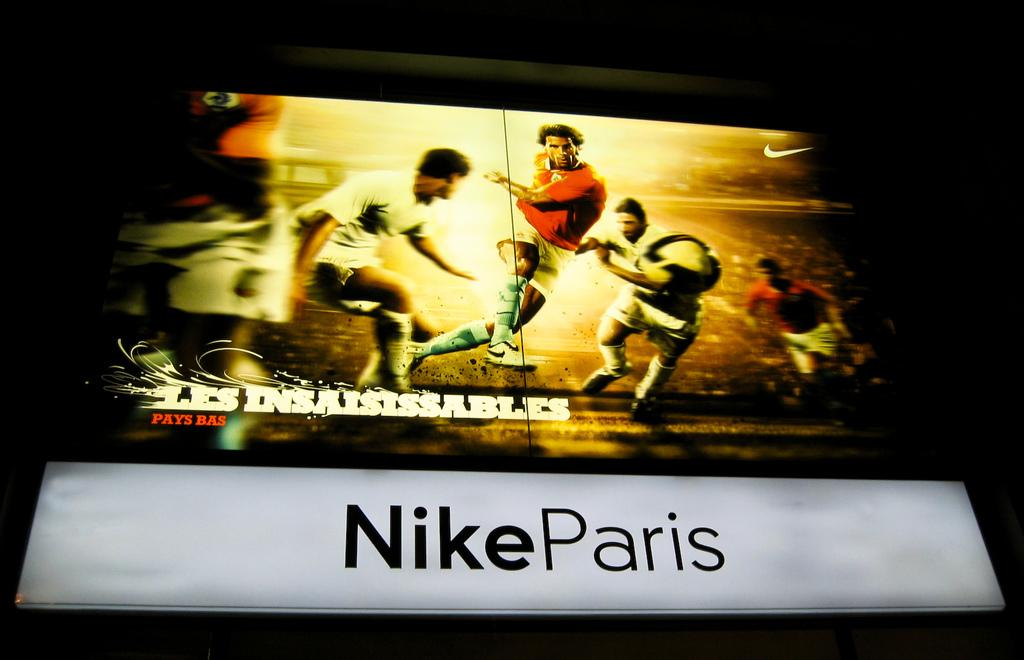What is the main object in the image? There is a screen in the image. Can you describe the people visible in the image? There are people visible in the image. What else can be seen on the screen besides the people? Text is present in the image. What type of division can be seen between the people in the image? There is no division visible between the people in the image; they are all on the same screen. Is there a stove present in the image? No, there is no stove present in the image. 